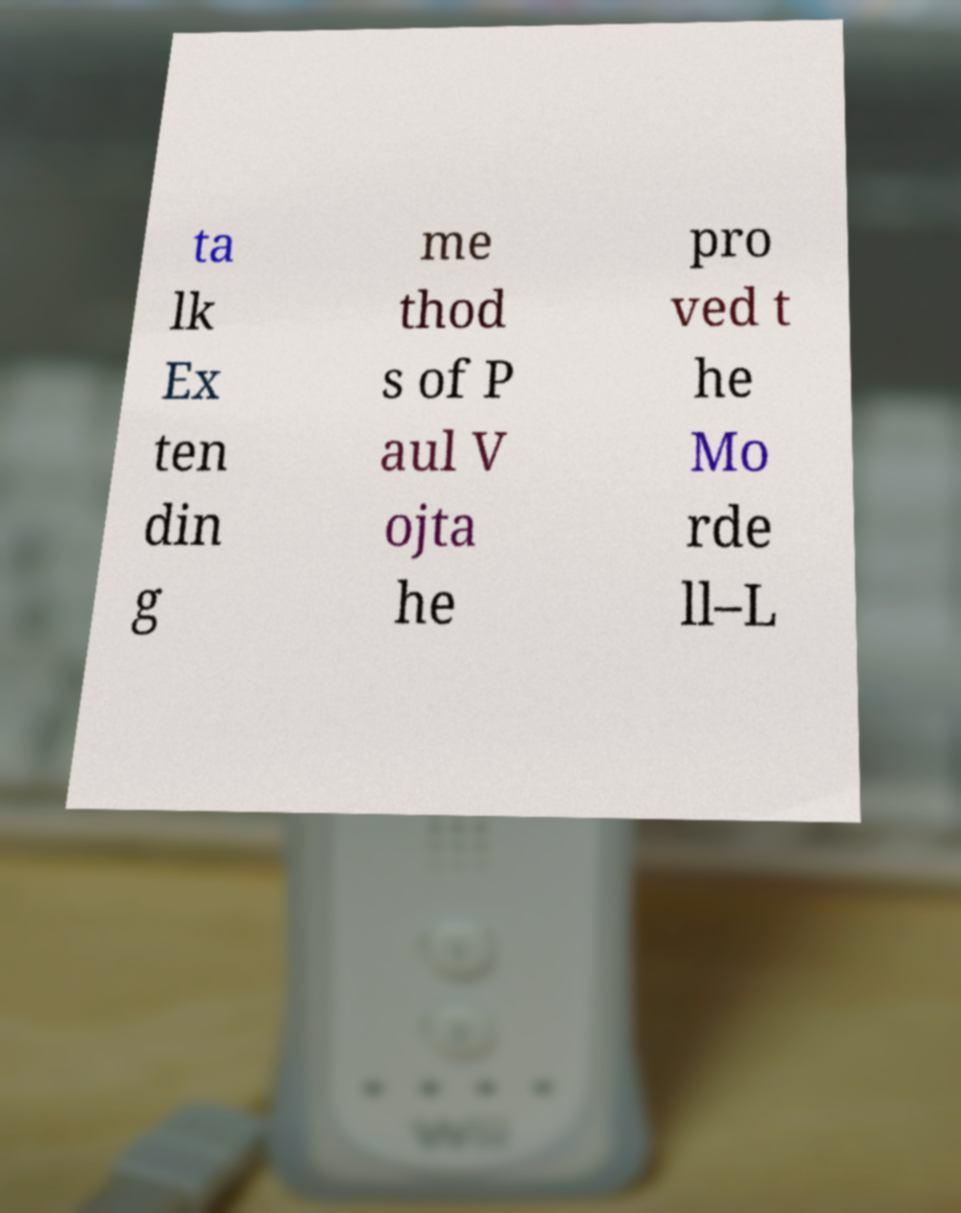For documentation purposes, I need the text within this image transcribed. Could you provide that? ta lk Ex ten din g me thod s of P aul V ojta he pro ved t he Mo rde ll–L 